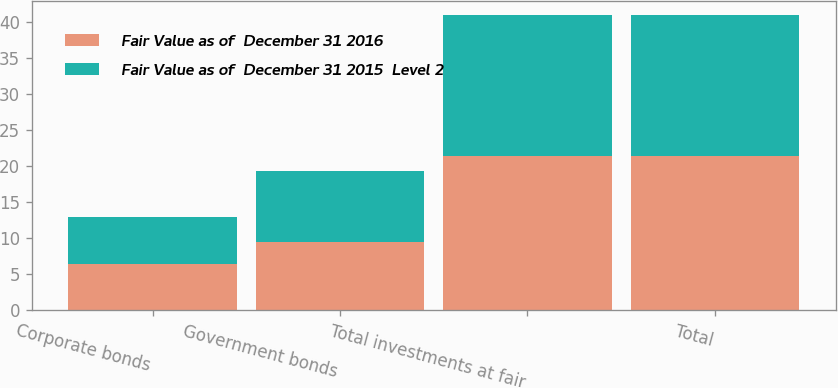Convert chart. <chart><loc_0><loc_0><loc_500><loc_500><stacked_bar_chart><ecel><fcel>Corporate bonds<fcel>Government bonds<fcel>Total investments at fair<fcel>Total<nl><fcel>Fair Value as of  December 31 2016<fcel>6.4<fcel>9.5<fcel>21.4<fcel>21.4<nl><fcel>Fair Value as of  December 31 2015  Level 2<fcel>6.6<fcel>9.8<fcel>19.5<fcel>19.5<nl></chart> 